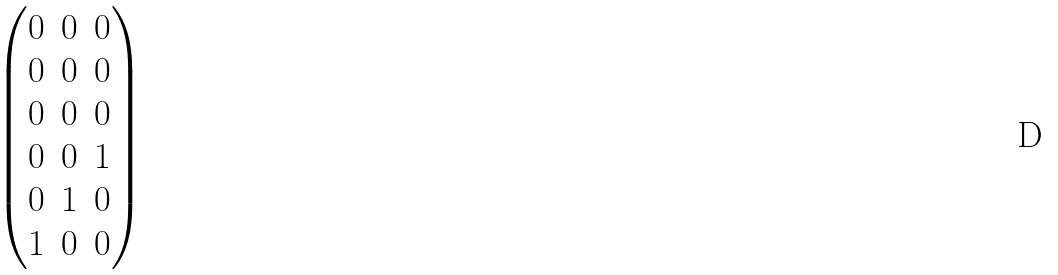Convert formula to latex. <formula><loc_0><loc_0><loc_500><loc_500>\begin{pmatrix} 0 & 0 & 0 \\ 0 & 0 & 0 \\ 0 & 0 & 0 \\ 0 & 0 & 1 \\ 0 & 1 & 0 \\ 1 & 0 & 0 \end{pmatrix}</formula> 